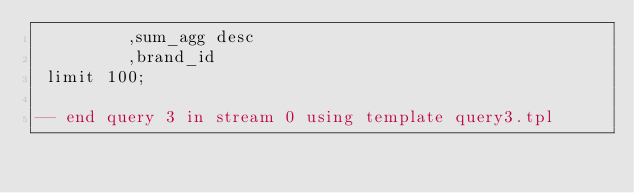<code> <loc_0><loc_0><loc_500><loc_500><_SQL_>         ,sum_agg desc
         ,brand_id
 limit 100;

-- end query 3 in stream 0 using template query3.tpl
</code> 